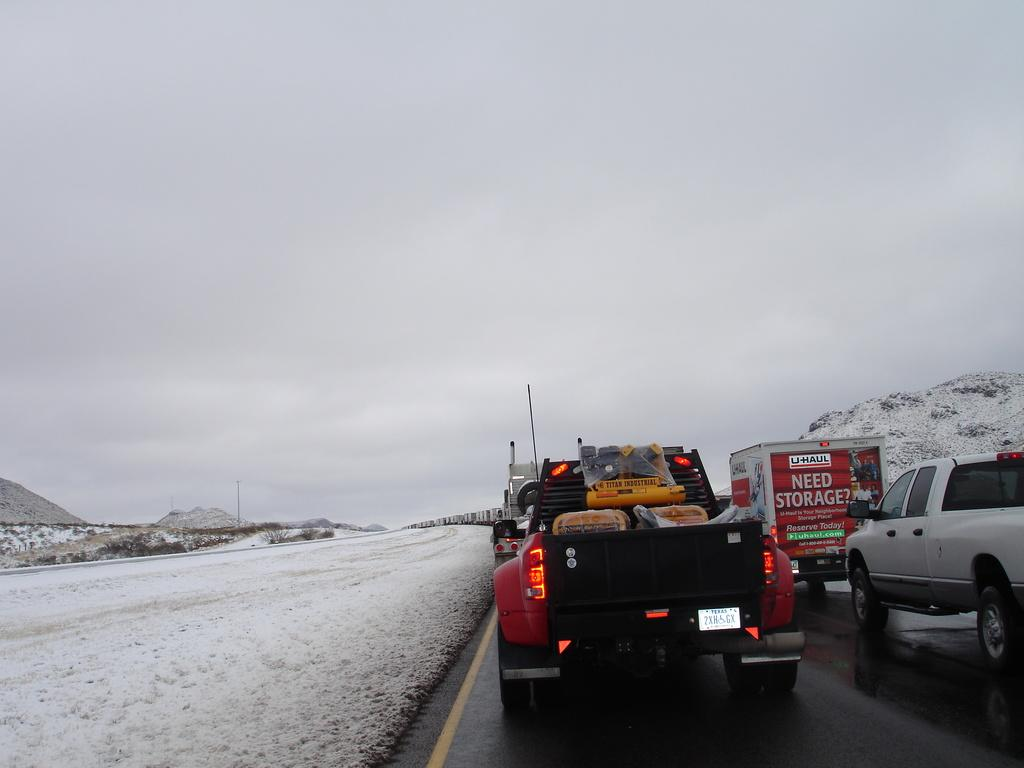What is happening on the road in the image? Vehicles are moving on the road towards the right. What can be seen on the left side of the image? There is snow on the left side of the image. What is visible in the background towards the left? Trees and hills are visible in the background towards the left. Can you describe the hill on the left side of the image? There is a hill on the left side of the image. How would you describe the sky in the image? The sky is cloudy. Where is the frame of the image located? The frame of the image is not visible in the image itself, as it is the border surrounding the image. Can you tell me how many houses are in the town shown in the image? There is no town shown in the image; it features a road, snow, trees, hills, and a cloudy sky. 